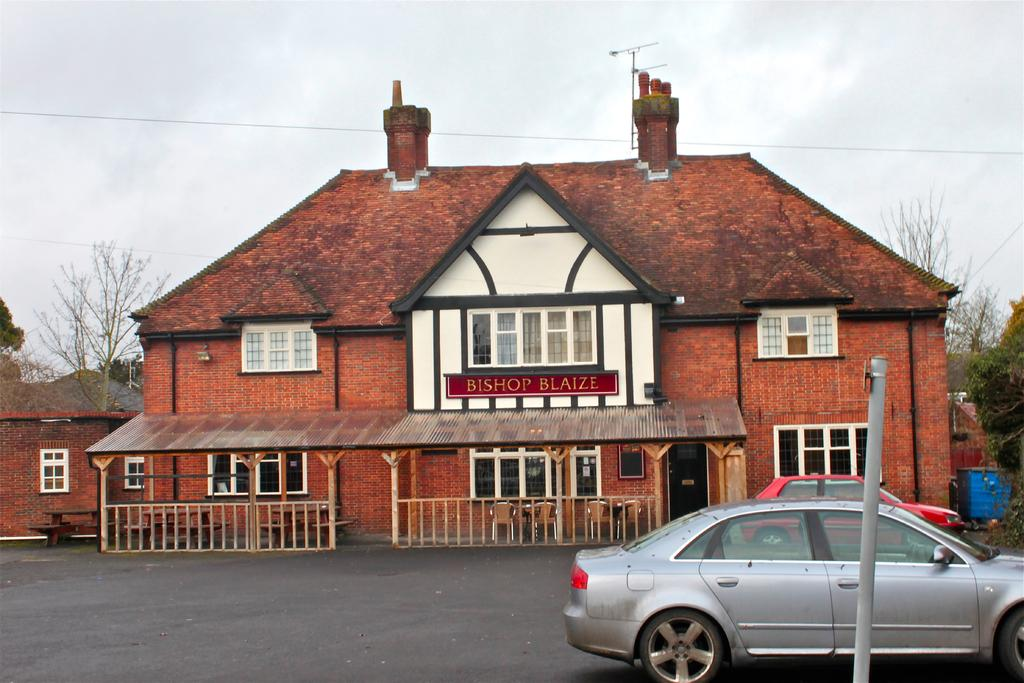What type of structures can be seen in the image? There are houses in the image. What is a feature of the houses? There are windows in the houses. What is present on the ground in the image? There is a road in the image. What is used for transportation in the image? There are cars in the image. What are some objects that provide support or guidance in the image? There are poles and railings in the image. What type of furniture is visible in the image? There are chairs in the image. What is a large, flat surface in the image? There is a board in the image. What type of seating is available for people in the image? There are benches in the image. What can be seen in the background of the image? Trees and the sky are visible in the background of the image. What is present in the sky? Clouds are present in the sky. What type of sheet is draped over the trees in the image? There is no sheet present in the image; only trees and the sky are visible in the background. How many cherries are hanging from the poles in the image? There are no cherries present in the image; only poles and railings are visible. 